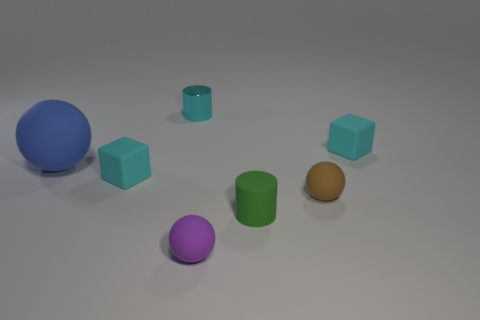Are the small purple ball and the cyan cylinder made of the same material?
Offer a very short reply. No. Is there any other thing that is made of the same material as the tiny cyan cylinder?
Provide a succinct answer. No. What material is the other large object that is the same shape as the purple object?
Provide a succinct answer. Rubber. Is the number of small rubber balls to the left of the cyan cylinder less than the number of large green metallic cubes?
Offer a terse response. No. There is a small green rubber cylinder; what number of brown balls are to the left of it?
Offer a terse response. 0. Does the tiny cyan thing that is right of the purple matte thing have the same shape as the green thing in front of the blue object?
Provide a short and direct response. No. There is a object that is right of the large blue sphere and to the left of the shiny object; what shape is it?
Your answer should be compact. Cube. What is the size of the blue ball that is made of the same material as the green object?
Your response must be concise. Large. Is the number of small purple rubber objects less than the number of rubber objects?
Offer a very short reply. Yes. There is a cylinder that is left of the matte thing that is in front of the small cylinder that is to the right of the purple rubber ball; what is it made of?
Your response must be concise. Metal. 